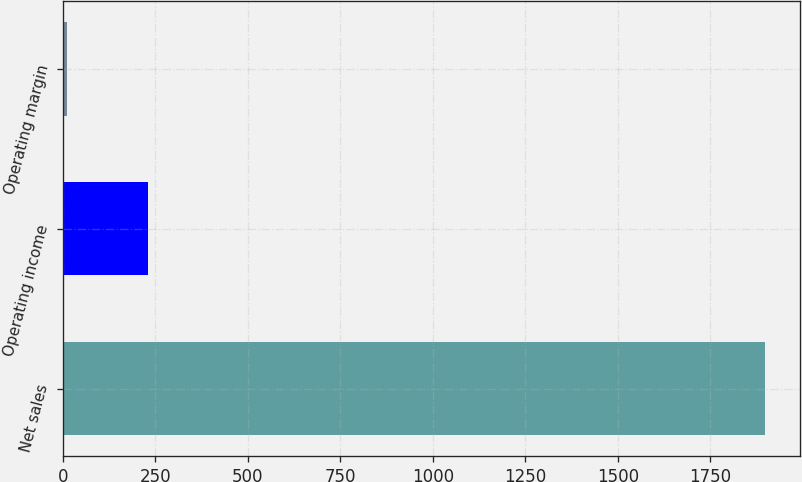Convert chart. <chart><loc_0><loc_0><loc_500><loc_500><bar_chart><fcel>Net sales<fcel>Operating income<fcel>Operating margin<nl><fcel>1897<fcel>229<fcel>12.1<nl></chart> 